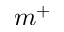Convert formula to latex. <formula><loc_0><loc_0><loc_500><loc_500>m ^ { + }</formula> 